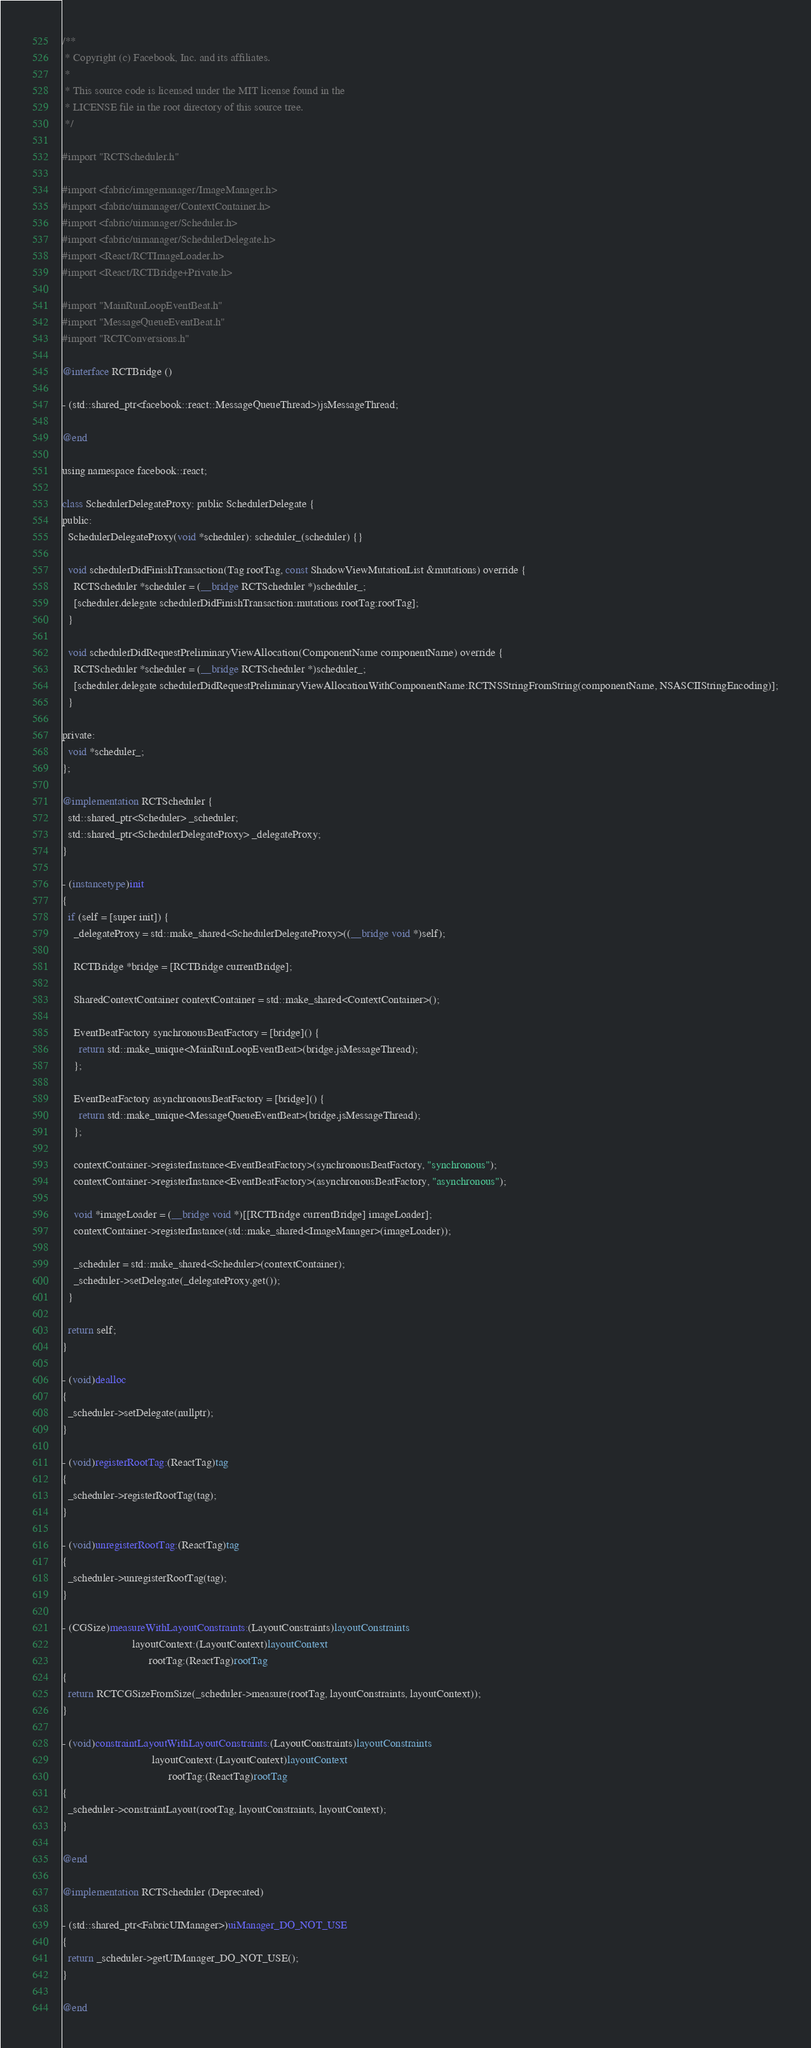<code> <loc_0><loc_0><loc_500><loc_500><_ObjectiveC_>/**
 * Copyright (c) Facebook, Inc. and its affiliates.
 *
 * This source code is licensed under the MIT license found in the
 * LICENSE file in the root directory of this source tree.
 */

#import "RCTScheduler.h"

#import <fabric/imagemanager/ImageManager.h>
#import <fabric/uimanager/ContextContainer.h>
#import <fabric/uimanager/Scheduler.h>
#import <fabric/uimanager/SchedulerDelegate.h>
#import <React/RCTImageLoader.h>
#import <React/RCTBridge+Private.h>

#import "MainRunLoopEventBeat.h"
#import "MessageQueueEventBeat.h"
#import "RCTConversions.h"

@interface RCTBridge ()

- (std::shared_ptr<facebook::react::MessageQueueThread>)jsMessageThread;

@end

using namespace facebook::react;

class SchedulerDelegateProxy: public SchedulerDelegate {
public:
  SchedulerDelegateProxy(void *scheduler): scheduler_(scheduler) {}

  void schedulerDidFinishTransaction(Tag rootTag, const ShadowViewMutationList &mutations) override {
    RCTScheduler *scheduler = (__bridge RCTScheduler *)scheduler_;
    [scheduler.delegate schedulerDidFinishTransaction:mutations rootTag:rootTag];
  }

  void schedulerDidRequestPreliminaryViewAllocation(ComponentName componentName) override {
    RCTScheduler *scheduler = (__bridge RCTScheduler *)scheduler_;
    [scheduler.delegate schedulerDidRequestPreliminaryViewAllocationWithComponentName:RCTNSStringFromString(componentName, NSASCIIStringEncoding)];
  }

private:
  void *scheduler_;
};

@implementation RCTScheduler {
  std::shared_ptr<Scheduler> _scheduler;
  std::shared_ptr<SchedulerDelegateProxy> _delegateProxy;
}

- (instancetype)init
{
  if (self = [super init]) {
    _delegateProxy = std::make_shared<SchedulerDelegateProxy>((__bridge void *)self);

    RCTBridge *bridge = [RCTBridge currentBridge];

    SharedContextContainer contextContainer = std::make_shared<ContextContainer>();

    EventBeatFactory synchronousBeatFactory = [bridge]() {
      return std::make_unique<MainRunLoopEventBeat>(bridge.jsMessageThread);
    };

    EventBeatFactory asynchronousBeatFactory = [bridge]() {
      return std::make_unique<MessageQueueEventBeat>(bridge.jsMessageThread);
    };

    contextContainer->registerInstance<EventBeatFactory>(synchronousBeatFactory, "synchronous");
    contextContainer->registerInstance<EventBeatFactory>(asynchronousBeatFactory, "asynchronous");

    void *imageLoader = (__bridge void *)[[RCTBridge currentBridge] imageLoader];
    contextContainer->registerInstance(std::make_shared<ImageManager>(imageLoader));

    _scheduler = std::make_shared<Scheduler>(contextContainer);
    _scheduler->setDelegate(_delegateProxy.get());
  }

  return self;
}

- (void)dealloc
{
  _scheduler->setDelegate(nullptr);
}

- (void)registerRootTag:(ReactTag)tag
{
  _scheduler->registerRootTag(tag);
}

- (void)unregisterRootTag:(ReactTag)tag
{
  _scheduler->unregisterRootTag(tag);
}

- (CGSize)measureWithLayoutConstraints:(LayoutConstraints)layoutConstraints
                         layoutContext:(LayoutContext)layoutContext
                               rootTag:(ReactTag)rootTag
{
  return RCTCGSizeFromSize(_scheduler->measure(rootTag, layoutConstraints, layoutContext));
}

- (void)constraintLayoutWithLayoutConstraints:(LayoutConstraints)layoutConstraints
                                layoutContext:(LayoutContext)layoutContext
                                      rootTag:(ReactTag)rootTag
{
  _scheduler->constraintLayout(rootTag, layoutConstraints, layoutContext);
}

@end

@implementation RCTScheduler (Deprecated)

- (std::shared_ptr<FabricUIManager>)uiManager_DO_NOT_USE
{
  return _scheduler->getUIManager_DO_NOT_USE();
}

@end
</code> 